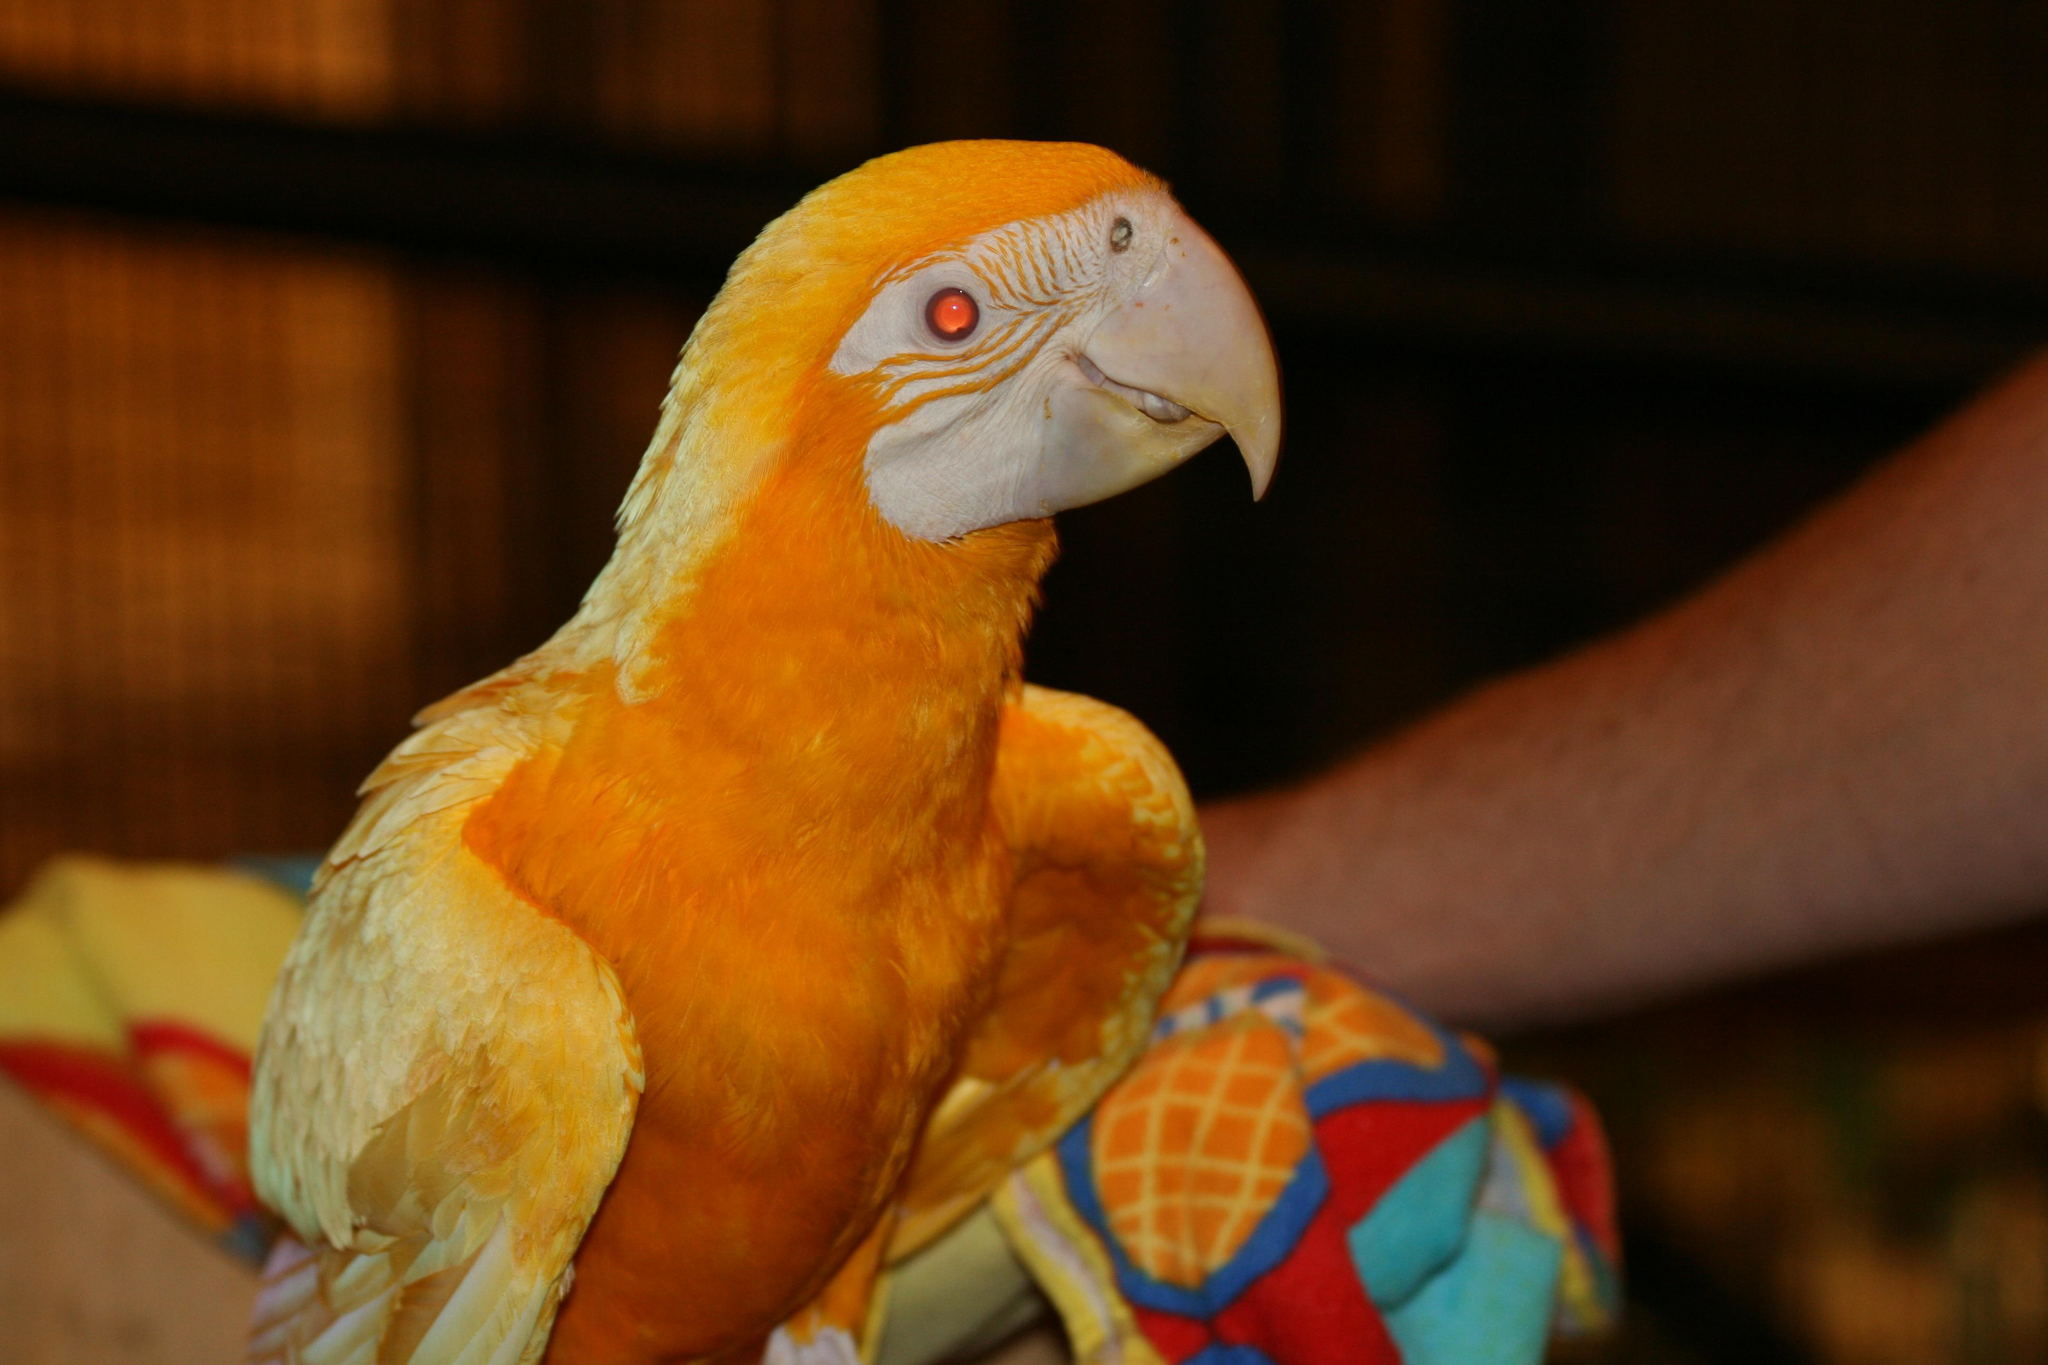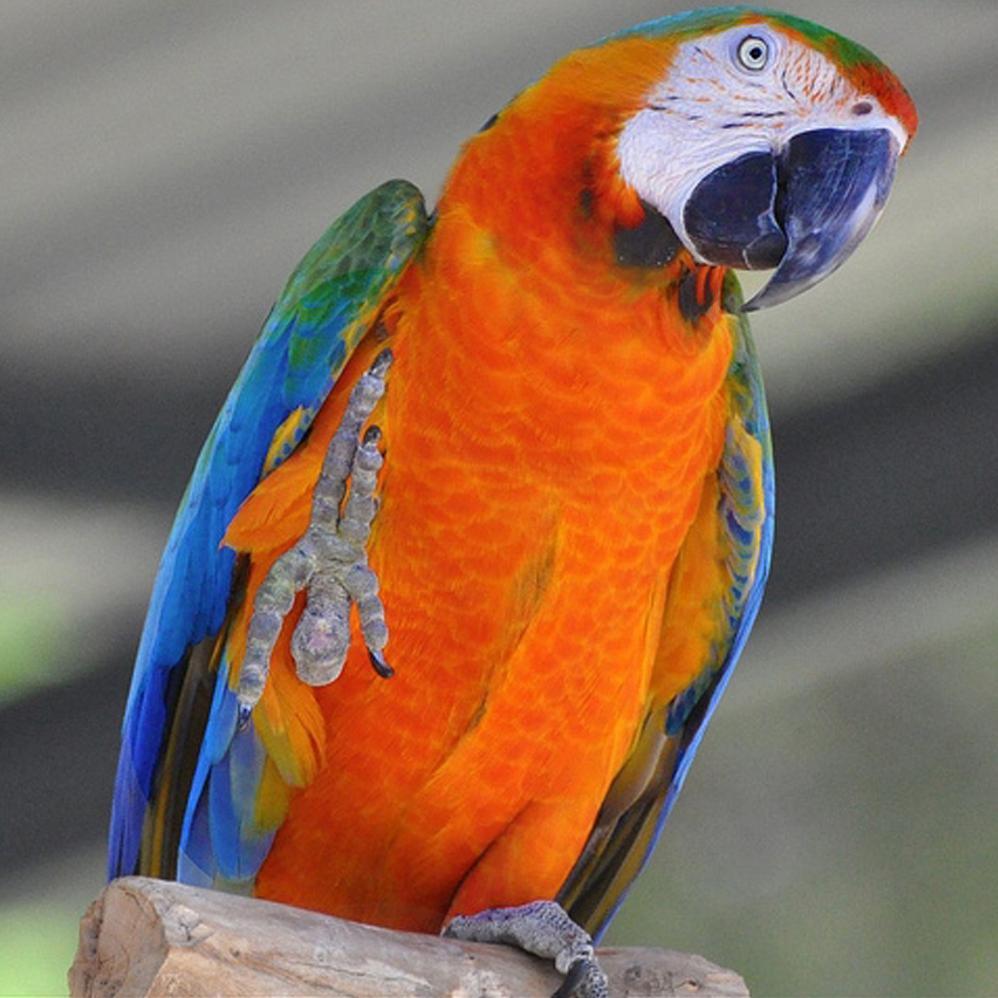The first image is the image on the left, the second image is the image on the right. Analyze the images presented: Is the assertion "Two parrots have the same eye design and beak colors." valid? Answer yes or no. No. The first image is the image on the left, the second image is the image on the right. For the images shown, is this caption "One image shows a parrot that is nearly all yellow-orange in color, without any blue." true? Answer yes or no. Yes. 